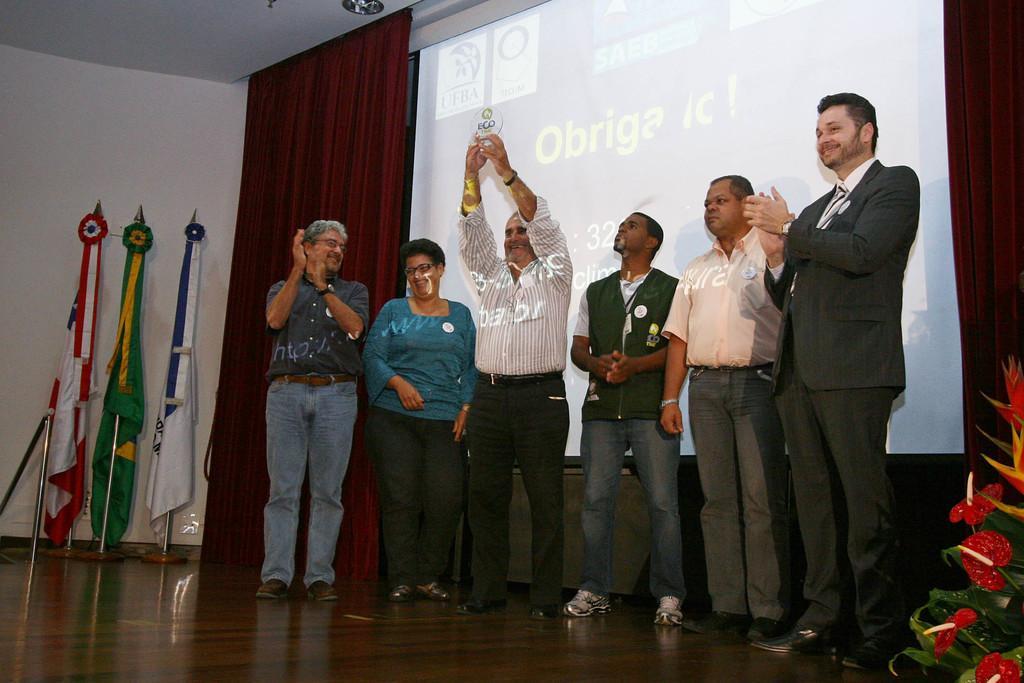Could you give a brief overview of what you see in this image? In this image I can see group of people standing. The person in front holding a shield and wearing white shirt, black pant. Background I can see a projector screen and three flags, they are in white, red, green, yellow color. 